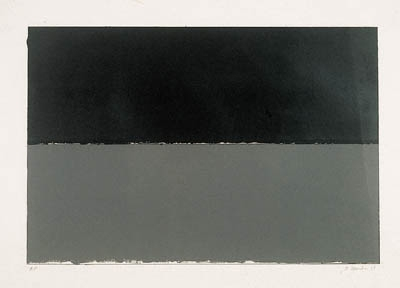How might the choice of colors influence our perception of this art? The colors in this minimalist art—predominantly black and gray with a stark white line—play a crucial role in shaping viewer perception. Black often represents sophistication or seriousness, while gray can induce feelings of neutrality and balance. The white line might be seen as a boundary or a division, introducing a visual break that can signify transition or contrast. Collectively, these colors work to create a piece that is both harmonious and thought-provoking, asking viewers to explore their own reactions to simplicity and duality in color. Could the simplicity of the design represent something more complex in its interpretation? Absolutely, the simplicity of the design in minimalist art often serves as a canvas for more complex interpretations. What appears as merely two colored rectangles with a separating line can represent duality—light and dark, yin and yang, emptiness and fullness—inviting viewers to consider deeper philosophical or existential questions. The minimalistic design challenges viewers to fill the visual 'void' with personal meaning or emotional resonance, making what is simple on the surface rich with potential depth and interpretation. 